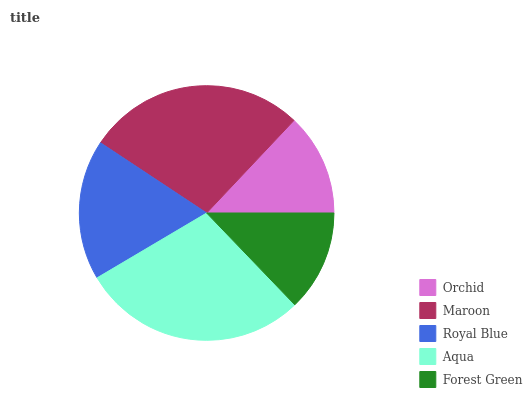Is Forest Green the minimum?
Answer yes or no. Yes. Is Aqua the maximum?
Answer yes or no. Yes. Is Maroon the minimum?
Answer yes or no. No. Is Maroon the maximum?
Answer yes or no. No. Is Maroon greater than Orchid?
Answer yes or no. Yes. Is Orchid less than Maroon?
Answer yes or no. Yes. Is Orchid greater than Maroon?
Answer yes or no. No. Is Maroon less than Orchid?
Answer yes or no. No. Is Royal Blue the high median?
Answer yes or no. Yes. Is Royal Blue the low median?
Answer yes or no. Yes. Is Forest Green the high median?
Answer yes or no. No. Is Aqua the low median?
Answer yes or no. No. 